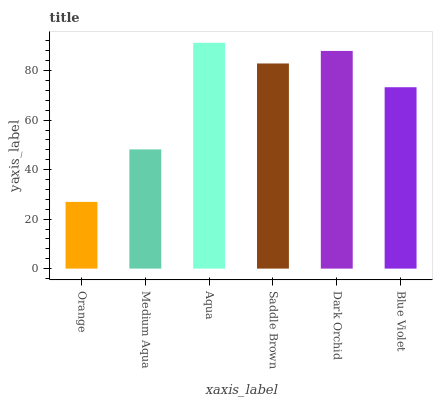Is Orange the minimum?
Answer yes or no. Yes. Is Aqua the maximum?
Answer yes or no. Yes. Is Medium Aqua the minimum?
Answer yes or no. No. Is Medium Aqua the maximum?
Answer yes or no. No. Is Medium Aqua greater than Orange?
Answer yes or no. Yes. Is Orange less than Medium Aqua?
Answer yes or no. Yes. Is Orange greater than Medium Aqua?
Answer yes or no. No. Is Medium Aqua less than Orange?
Answer yes or no. No. Is Saddle Brown the high median?
Answer yes or no. Yes. Is Blue Violet the low median?
Answer yes or no. Yes. Is Aqua the high median?
Answer yes or no. No. Is Aqua the low median?
Answer yes or no. No. 